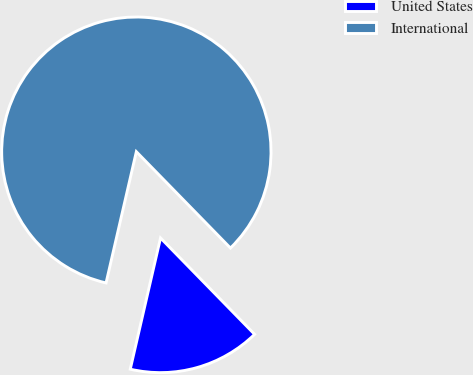<chart> <loc_0><loc_0><loc_500><loc_500><pie_chart><fcel>United States<fcel>International<nl><fcel>15.92%<fcel>84.08%<nl></chart> 